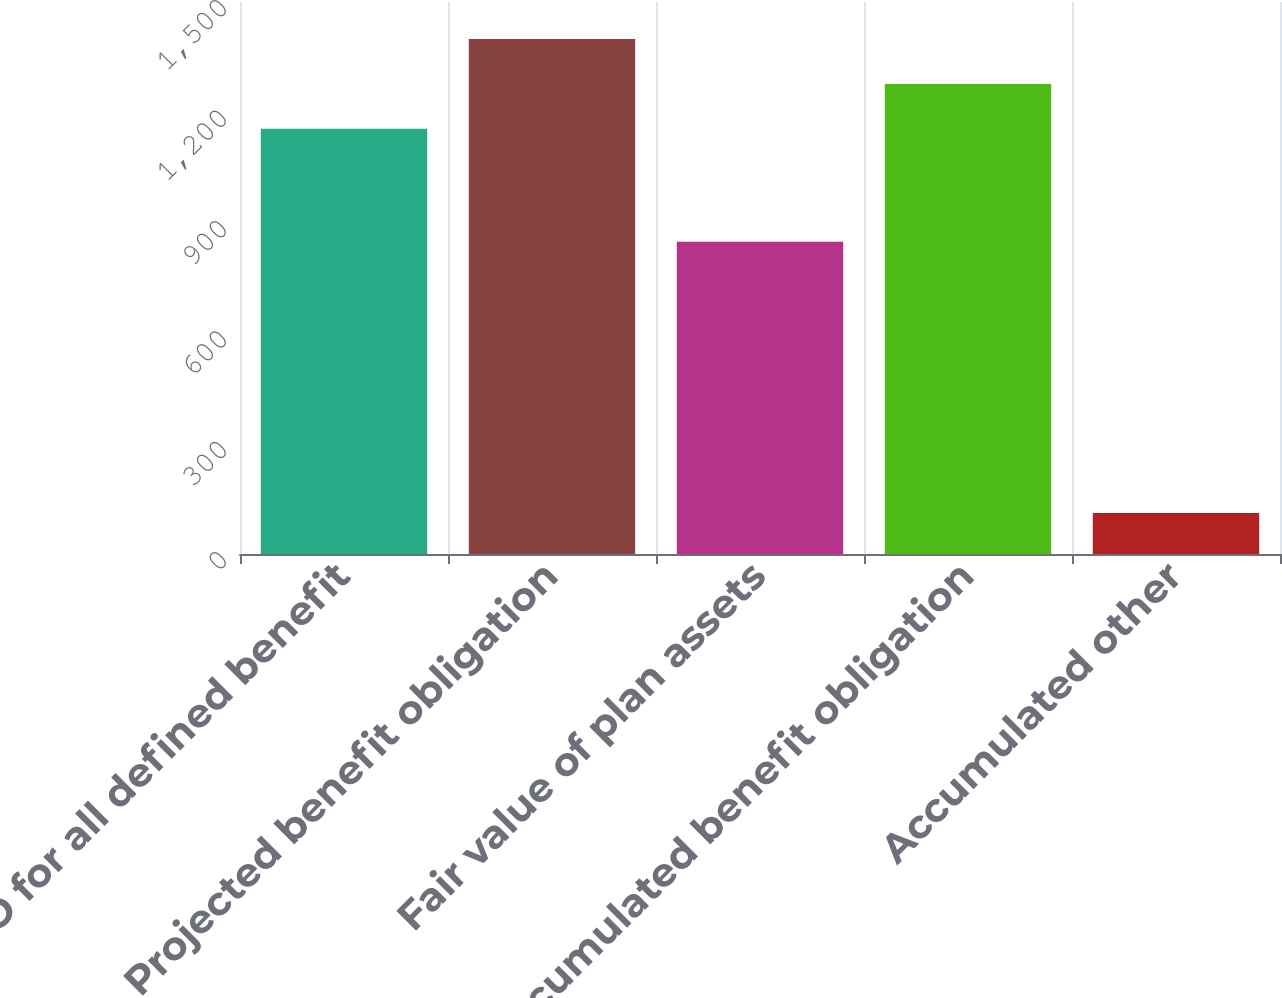Convert chart. <chart><loc_0><loc_0><loc_500><loc_500><bar_chart><fcel>ABO for all defined benefit<fcel>Projected benefit obligation<fcel>Fair value of plan assets<fcel>Accumulated benefit obligation<fcel>Accumulated other<nl><fcel>1155.5<fcel>1399.52<fcel>848.4<fcel>1277.51<fcel>111.6<nl></chart> 